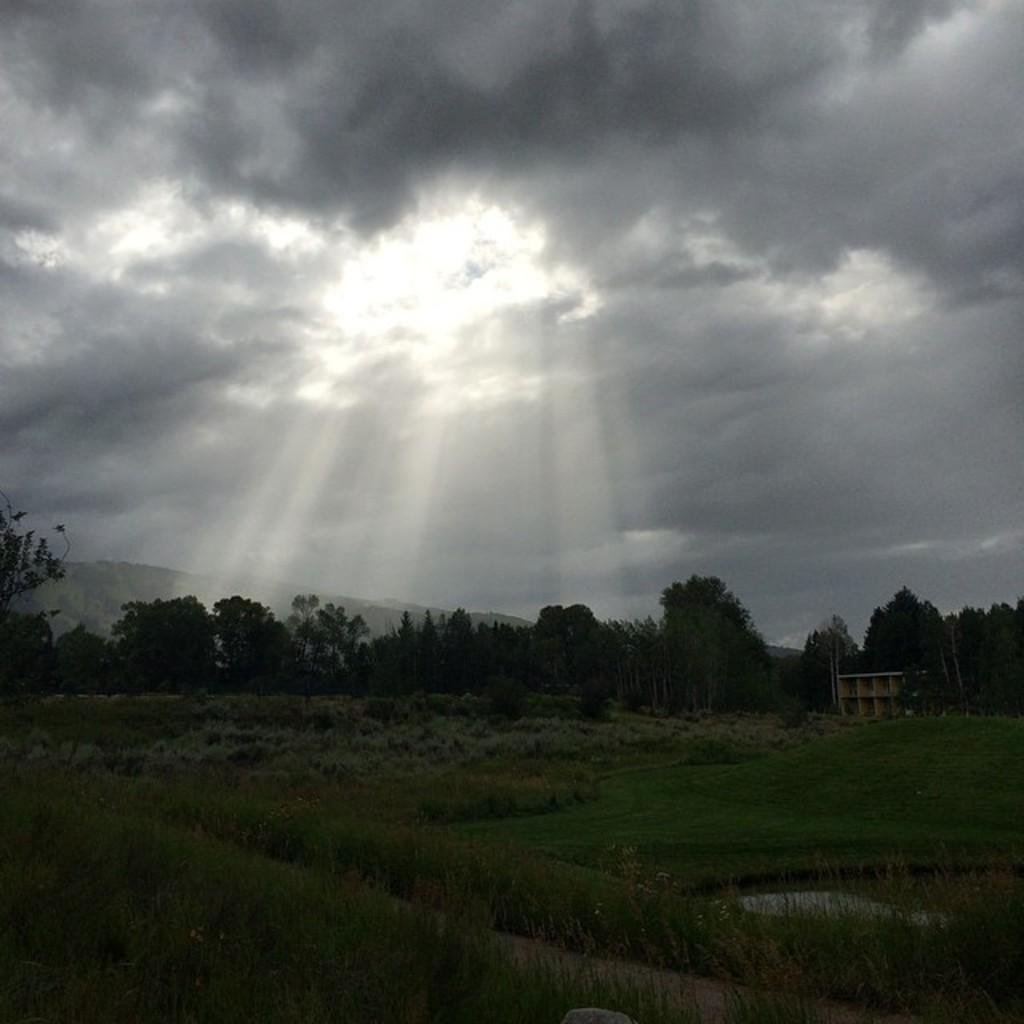What type of vegetation can be seen in the image? There are trees, plants, and grass visible in the image. What type of structure is present in the image? There is a building in the image. What part of the natural environment is visible in the image? The sky is visible in the image. Can you see any berries growing on the grass in the image? There is no mention of berries in the image, and therefore it cannot be determined if any are growing on the grass. Is there any ice visible in the image? There is no mention of ice in the image, and therefore it cannot be determined if any is visible. 